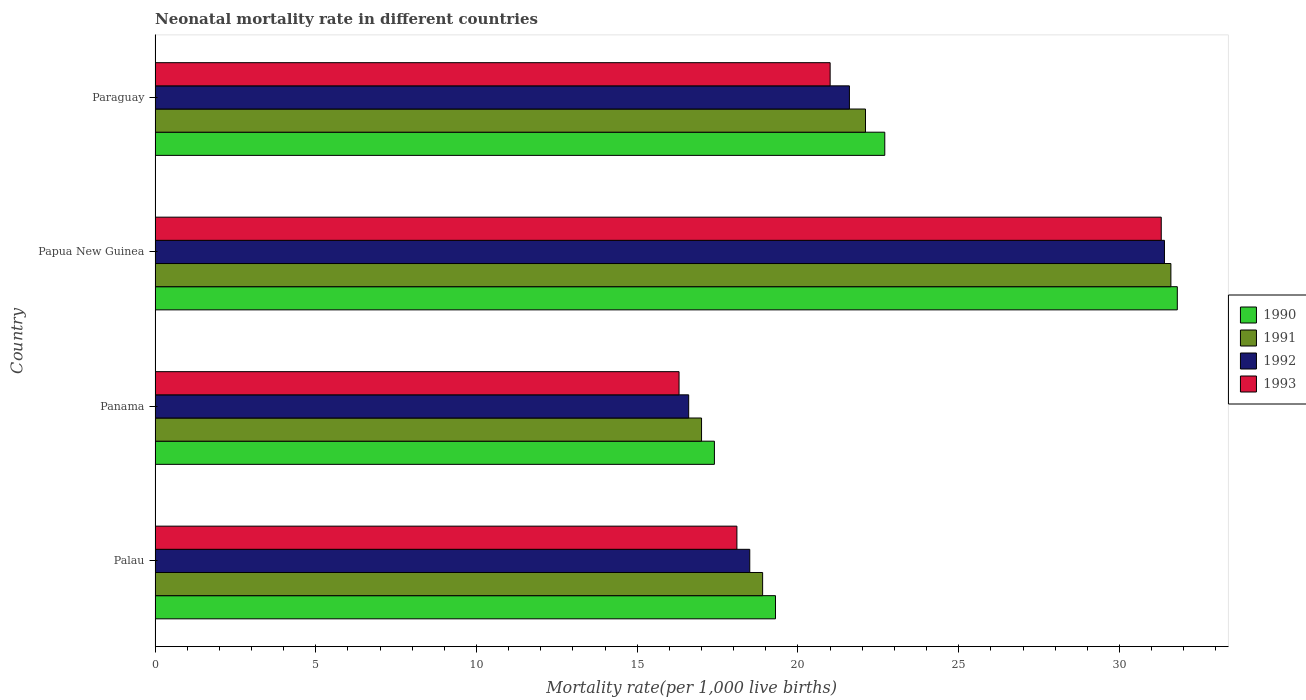Are the number of bars on each tick of the Y-axis equal?
Ensure brevity in your answer.  Yes. How many bars are there on the 1st tick from the top?
Give a very brief answer. 4. How many bars are there on the 4th tick from the bottom?
Make the answer very short. 4. What is the label of the 3rd group of bars from the top?
Provide a short and direct response. Panama. What is the neonatal mortality rate in 1991 in Panama?
Offer a very short reply. 17. Across all countries, what is the maximum neonatal mortality rate in 1992?
Offer a terse response. 31.4. Across all countries, what is the minimum neonatal mortality rate in 1992?
Your response must be concise. 16.6. In which country was the neonatal mortality rate in 1992 maximum?
Make the answer very short. Papua New Guinea. In which country was the neonatal mortality rate in 1991 minimum?
Offer a terse response. Panama. What is the total neonatal mortality rate in 1993 in the graph?
Make the answer very short. 86.7. What is the difference between the neonatal mortality rate in 1991 in Palau and that in Paraguay?
Provide a short and direct response. -3.2. What is the average neonatal mortality rate in 1991 per country?
Ensure brevity in your answer.  22.4. What is the difference between the neonatal mortality rate in 1990 and neonatal mortality rate in 1991 in Paraguay?
Make the answer very short. 0.6. What is the ratio of the neonatal mortality rate in 1990 in Panama to that in Papua New Guinea?
Keep it short and to the point. 0.55. Is the neonatal mortality rate in 1990 in Palau less than that in Panama?
Your answer should be very brief. No. What is the difference between the highest and the second highest neonatal mortality rate in 1990?
Make the answer very short. 9.1. Is the sum of the neonatal mortality rate in 1993 in Papua New Guinea and Paraguay greater than the maximum neonatal mortality rate in 1990 across all countries?
Offer a terse response. Yes. Is it the case that in every country, the sum of the neonatal mortality rate in 1993 and neonatal mortality rate in 1991 is greater than the sum of neonatal mortality rate in 1992 and neonatal mortality rate in 1990?
Provide a succinct answer. No. How many bars are there?
Provide a short and direct response. 16. Are all the bars in the graph horizontal?
Give a very brief answer. Yes. How many countries are there in the graph?
Your answer should be compact. 4. Are the values on the major ticks of X-axis written in scientific E-notation?
Provide a short and direct response. No. Does the graph contain any zero values?
Your answer should be compact. No. Does the graph contain grids?
Make the answer very short. No. Where does the legend appear in the graph?
Provide a short and direct response. Center right. How many legend labels are there?
Ensure brevity in your answer.  4. What is the title of the graph?
Your answer should be very brief. Neonatal mortality rate in different countries. What is the label or title of the X-axis?
Offer a very short reply. Mortality rate(per 1,0 live births). What is the Mortality rate(per 1,000 live births) in 1990 in Palau?
Your response must be concise. 19.3. What is the Mortality rate(per 1,000 live births) in 1993 in Palau?
Your answer should be compact. 18.1. What is the Mortality rate(per 1,000 live births) of 1990 in Papua New Guinea?
Keep it short and to the point. 31.8. What is the Mortality rate(per 1,000 live births) of 1991 in Papua New Guinea?
Your answer should be very brief. 31.6. What is the Mortality rate(per 1,000 live births) in 1992 in Papua New Guinea?
Your answer should be compact. 31.4. What is the Mortality rate(per 1,000 live births) of 1993 in Papua New Guinea?
Your answer should be compact. 31.3. What is the Mortality rate(per 1,000 live births) of 1990 in Paraguay?
Make the answer very short. 22.7. What is the Mortality rate(per 1,000 live births) of 1991 in Paraguay?
Give a very brief answer. 22.1. What is the Mortality rate(per 1,000 live births) of 1992 in Paraguay?
Your response must be concise. 21.6. What is the Mortality rate(per 1,000 live births) of 1993 in Paraguay?
Your response must be concise. 21. Across all countries, what is the maximum Mortality rate(per 1,000 live births) of 1990?
Offer a very short reply. 31.8. Across all countries, what is the maximum Mortality rate(per 1,000 live births) of 1991?
Keep it short and to the point. 31.6. Across all countries, what is the maximum Mortality rate(per 1,000 live births) in 1992?
Your answer should be compact. 31.4. Across all countries, what is the maximum Mortality rate(per 1,000 live births) of 1993?
Offer a very short reply. 31.3. Across all countries, what is the minimum Mortality rate(per 1,000 live births) in 1990?
Offer a terse response. 17.4. Across all countries, what is the minimum Mortality rate(per 1,000 live births) of 1992?
Your answer should be very brief. 16.6. What is the total Mortality rate(per 1,000 live births) of 1990 in the graph?
Give a very brief answer. 91.2. What is the total Mortality rate(per 1,000 live births) in 1991 in the graph?
Provide a succinct answer. 89.6. What is the total Mortality rate(per 1,000 live births) of 1992 in the graph?
Provide a succinct answer. 88.1. What is the total Mortality rate(per 1,000 live births) of 1993 in the graph?
Offer a very short reply. 86.7. What is the difference between the Mortality rate(per 1,000 live births) of 1991 in Palau and that in Panama?
Offer a very short reply. 1.9. What is the difference between the Mortality rate(per 1,000 live births) in 1990 in Palau and that in Papua New Guinea?
Make the answer very short. -12.5. What is the difference between the Mortality rate(per 1,000 live births) in 1992 in Palau and that in Papua New Guinea?
Make the answer very short. -12.9. What is the difference between the Mortality rate(per 1,000 live births) in 1991 in Palau and that in Paraguay?
Keep it short and to the point. -3.2. What is the difference between the Mortality rate(per 1,000 live births) in 1992 in Palau and that in Paraguay?
Provide a short and direct response. -3.1. What is the difference between the Mortality rate(per 1,000 live births) of 1993 in Palau and that in Paraguay?
Your response must be concise. -2.9. What is the difference between the Mortality rate(per 1,000 live births) of 1990 in Panama and that in Papua New Guinea?
Your response must be concise. -14.4. What is the difference between the Mortality rate(per 1,000 live births) of 1991 in Panama and that in Papua New Guinea?
Give a very brief answer. -14.6. What is the difference between the Mortality rate(per 1,000 live births) of 1992 in Panama and that in Papua New Guinea?
Keep it short and to the point. -14.8. What is the difference between the Mortality rate(per 1,000 live births) of 1990 in Panama and that in Paraguay?
Your answer should be compact. -5.3. What is the difference between the Mortality rate(per 1,000 live births) of 1993 in Panama and that in Paraguay?
Ensure brevity in your answer.  -4.7. What is the difference between the Mortality rate(per 1,000 live births) of 1993 in Papua New Guinea and that in Paraguay?
Provide a short and direct response. 10.3. What is the difference between the Mortality rate(per 1,000 live births) in 1990 in Palau and the Mortality rate(per 1,000 live births) in 1991 in Panama?
Offer a terse response. 2.3. What is the difference between the Mortality rate(per 1,000 live births) of 1990 in Palau and the Mortality rate(per 1,000 live births) of 1992 in Panama?
Give a very brief answer. 2.7. What is the difference between the Mortality rate(per 1,000 live births) of 1990 in Palau and the Mortality rate(per 1,000 live births) of 1993 in Panama?
Make the answer very short. 3. What is the difference between the Mortality rate(per 1,000 live births) of 1991 in Palau and the Mortality rate(per 1,000 live births) of 1992 in Panama?
Offer a very short reply. 2.3. What is the difference between the Mortality rate(per 1,000 live births) in 1992 in Palau and the Mortality rate(per 1,000 live births) in 1993 in Panama?
Provide a succinct answer. 2.2. What is the difference between the Mortality rate(per 1,000 live births) of 1990 in Palau and the Mortality rate(per 1,000 live births) of 1991 in Papua New Guinea?
Ensure brevity in your answer.  -12.3. What is the difference between the Mortality rate(per 1,000 live births) in 1992 in Palau and the Mortality rate(per 1,000 live births) in 1993 in Papua New Guinea?
Your answer should be very brief. -12.8. What is the difference between the Mortality rate(per 1,000 live births) in 1990 in Palau and the Mortality rate(per 1,000 live births) in 1992 in Paraguay?
Give a very brief answer. -2.3. What is the difference between the Mortality rate(per 1,000 live births) in 1991 in Palau and the Mortality rate(per 1,000 live births) in 1992 in Paraguay?
Offer a terse response. -2.7. What is the difference between the Mortality rate(per 1,000 live births) of 1991 in Palau and the Mortality rate(per 1,000 live births) of 1993 in Paraguay?
Give a very brief answer. -2.1. What is the difference between the Mortality rate(per 1,000 live births) of 1992 in Palau and the Mortality rate(per 1,000 live births) of 1993 in Paraguay?
Provide a succinct answer. -2.5. What is the difference between the Mortality rate(per 1,000 live births) in 1991 in Panama and the Mortality rate(per 1,000 live births) in 1992 in Papua New Guinea?
Give a very brief answer. -14.4. What is the difference between the Mortality rate(per 1,000 live births) in 1991 in Panama and the Mortality rate(per 1,000 live births) in 1993 in Papua New Guinea?
Keep it short and to the point. -14.3. What is the difference between the Mortality rate(per 1,000 live births) in 1992 in Panama and the Mortality rate(per 1,000 live births) in 1993 in Papua New Guinea?
Keep it short and to the point. -14.7. What is the difference between the Mortality rate(per 1,000 live births) in 1990 in Panama and the Mortality rate(per 1,000 live births) in 1992 in Paraguay?
Offer a very short reply. -4.2. What is the difference between the Mortality rate(per 1,000 live births) of 1990 in Papua New Guinea and the Mortality rate(per 1,000 live births) of 1991 in Paraguay?
Your response must be concise. 9.7. What is the difference between the Mortality rate(per 1,000 live births) of 1991 in Papua New Guinea and the Mortality rate(per 1,000 live births) of 1993 in Paraguay?
Provide a succinct answer. 10.6. What is the difference between the Mortality rate(per 1,000 live births) in 1992 in Papua New Guinea and the Mortality rate(per 1,000 live births) in 1993 in Paraguay?
Give a very brief answer. 10.4. What is the average Mortality rate(per 1,000 live births) in 1990 per country?
Your response must be concise. 22.8. What is the average Mortality rate(per 1,000 live births) in 1991 per country?
Provide a succinct answer. 22.4. What is the average Mortality rate(per 1,000 live births) in 1992 per country?
Your response must be concise. 22.02. What is the average Mortality rate(per 1,000 live births) in 1993 per country?
Your answer should be very brief. 21.68. What is the difference between the Mortality rate(per 1,000 live births) of 1990 and Mortality rate(per 1,000 live births) of 1991 in Palau?
Your answer should be compact. 0.4. What is the difference between the Mortality rate(per 1,000 live births) in 1990 and Mortality rate(per 1,000 live births) in 1992 in Palau?
Provide a succinct answer. 0.8. What is the difference between the Mortality rate(per 1,000 live births) in 1990 and Mortality rate(per 1,000 live births) in 1993 in Palau?
Your answer should be very brief. 1.2. What is the difference between the Mortality rate(per 1,000 live births) in 1991 and Mortality rate(per 1,000 live births) in 1993 in Palau?
Offer a very short reply. 0.8. What is the difference between the Mortality rate(per 1,000 live births) in 1990 and Mortality rate(per 1,000 live births) in 1992 in Panama?
Your response must be concise. 0.8. What is the difference between the Mortality rate(per 1,000 live births) of 1990 and Mortality rate(per 1,000 live births) of 1993 in Panama?
Provide a succinct answer. 1.1. What is the difference between the Mortality rate(per 1,000 live births) in 1991 and Mortality rate(per 1,000 live births) in 1992 in Panama?
Provide a short and direct response. 0.4. What is the difference between the Mortality rate(per 1,000 live births) of 1992 and Mortality rate(per 1,000 live births) of 1993 in Panama?
Give a very brief answer. 0.3. What is the difference between the Mortality rate(per 1,000 live births) in 1990 and Mortality rate(per 1,000 live births) in 1992 in Papua New Guinea?
Your answer should be compact. 0.4. What is the difference between the Mortality rate(per 1,000 live births) in 1991 and Mortality rate(per 1,000 live births) in 1992 in Papua New Guinea?
Provide a short and direct response. 0.2. What is the difference between the Mortality rate(per 1,000 live births) of 1991 and Mortality rate(per 1,000 live births) of 1993 in Papua New Guinea?
Your response must be concise. 0.3. What is the difference between the Mortality rate(per 1,000 live births) in 1992 and Mortality rate(per 1,000 live births) in 1993 in Papua New Guinea?
Provide a succinct answer. 0.1. What is the difference between the Mortality rate(per 1,000 live births) of 1990 and Mortality rate(per 1,000 live births) of 1992 in Paraguay?
Provide a short and direct response. 1.1. What is the difference between the Mortality rate(per 1,000 live births) of 1990 and Mortality rate(per 1,000 live births) of 1993 in Paraguay?
Provide a succinct answer. 1.7. What is the difference between the Mortality rate(per 1,000 live births) of 1991 and Mortality rate(per 1,000 live births) of 1992 in Paraguay?
Your answer should be very brief. 0.5. What is the ratio of the Mortality rate(per 1,000 live births) in 1990 in Palau to that in Panama?
Make the answer very short. 1.11. What is the ratio of the Mortality rate(per 1,000 live births) of 1991 in Palau to that in Panama?
Provide a succinct answer. 1.11. What is the ratio of the Mortality rate(per 1,000 live births) in 1992 in Palau to that in Panama?
Give a very brief answer. 1.11. What is the ratio of the Mortality rate(per 1,000 live births) of 1993 in Palau to that in Panama?
Offer a terse response. 1.11. What is the ratio of the Mortality rate(per 1,000 live births) of 1990 in Palau to that in Papua New Guinea?
Your answer should be compact. 0.61. What is the ratio of the Mortality rate(per 1,000 live births) of 1991 in Palau to that in Papua New Guinea?
Your answer should be very brief. 0.6. What is the ratio of the Mortality rate(per 1,000 live births) of 1992 in Palau to that in Papua New Guinea?
Your answer should be very brief. 0.59. What is the ratio of the Mortality rate(per 1,000 live births) in 1993 in Palau to that in Papua New Guinea?
Keep it short and to the point. 0.58. What is the ratio of the Mortality rate(per 1,000 live births) of 1990 in Palau to that in Paraguay?
Your answer should be compact. 0.85. What is the ratio of the Mortality rate(per 1,000 live births) in 1991 in Palau to that in Paraguay?
Give a very brief answer. 0.86. What is the ratio of the Mortality rate(per 1,000 live births) in 1992 in Palau to that in Paraguay?
Your answer should be very brief. 0.86. What is the ratio of the Mortality rate(per 1,000 live births) in 1993 in Palau to that in Paraguay?
Make the answer very short. 0.86. What is the ratio of the Mortality rate(per 1,000 live births) of 1990 in Panama to that in Papua New Guinea?
Your response must be concise. 0.55. What is the ratio of the Mortality rate(per 1,000 live births) in 1991 in Panama to that in Papua New Guinea?
Provide a short and direct response. 0.54. What is the ratio of the Mortality rate(per 1,000 live births) in 1992 in Panama to that in Papua New Guinea?
Give a very brief answer. 0.53. What is the ratio of the Mortality rate(per 1,000 live births) in 1993 in Panama to that in Papua New Guinea?
Provide a short and direct response. 0.52. What is the ratio of the Mortality rate(per 1,000 live births) in 1990 in Panama to that in Paraguay?
Provide a short and direct response. 0.77. What is the ratio of the Mortality rate(per 1,000 live births) in 1991 in Panama to that in Paraguay?
Offer a very short reply. 0.77. What is the ratio of the Mortality rate(per 1,000 live births) of 1992 in Panama to that in Paraguay?
Your response must be concise. 0.77. What is the ratio of the Mortality rate(per 1,000 live births) in 1993 in Panama to that in Paraguay?
Give a very brief answer. 0.78. What is the ratio of the Mortality rate(per 1,000 live births) of 1990 in Papua New Guinea to that in Paraguay?
Your response must be concise. 1.4. What is the ratio of the Mortality rate(per 1,000 live births) in 1991 in Papua New Guinea to that in Paraguay?
Provide a succinct answer. 1.43. What is the ratio of the Mortality rate(per 1,000 live births) in 1992 in Papua New Guinea to that in Paraguay?
Your answer should be compact. 1.45. What is the ratio of the Mortality rate(per 1,000 live births) of 1993 in Papua New Guinea to that in Paraguay?
Ensure brevity in your answer.  1.49. What is the difference between the highest and the second highest Mortality rate(per 1,000 live births) of 1990?
Your answer should be compact. 9.1. What is the difference between the highest and the second highest Mortality rate(per 1,000 live births) in 1991?
Keep it short and to the point. 9.5. What is the difference between the highest and the second highest Mortality rate(per 1,000 live births) of 1992?
Make the answer very short. 9.8. What is the difference between the highest and the second highest Mortality rate(per 1,000 live births) of 1993?
Keep it short and to the point. 10.3. What is the difference between the highest and the lowest Mortality rate(per 1,000 live births) in 1991?
Offer a very short reply. 14.6. 